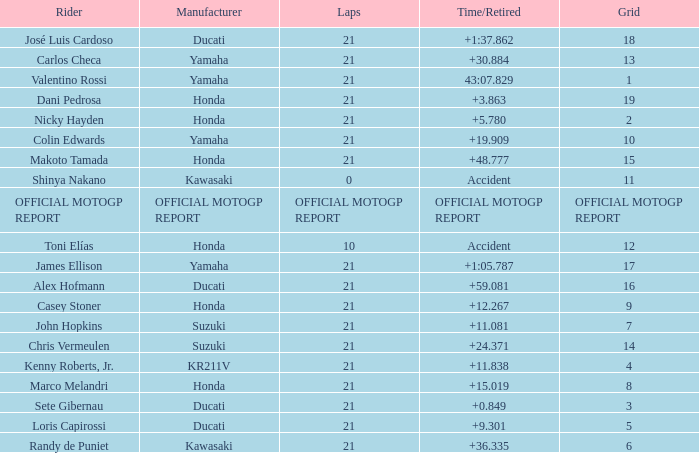When rider John Hopkins had 21 laps, what was the grid? 7.0. 